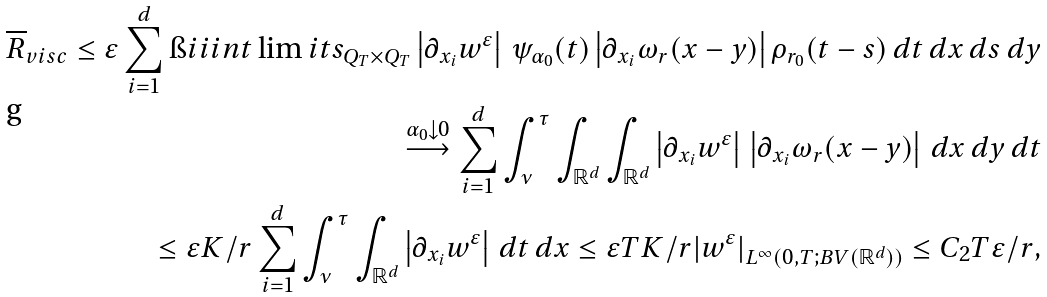<formula> <loc_0><loc_0><loc_500><loc_500>\overline { R } _ { v i s c } \leq \varepsilon \sum _ { i = 1 } ^ { d } \i i i i n t \lim i t s _ { Q _ { T } \times Q _ { T } } \left | \partial _ { x _ { i } } w ^ { \varepsilon } \right | \, \psi _ { \alpha _ { 0 } } ( t ) \left | \partial _ { x _ { i } } \omega _ { r } ( x - y ) \right | \rho _ { r _ { 0 } } ( t - s ) \, d t \, d x \, d s \, d y \\ \overset { \alpha _ { 0 } \downarrow 0 } { \longrightarrow } \sum _ { i = 1 } ^ { d } \int _ { \nu } ^ { \tau } \int _ { { \mathbb { R } } ^ { d } } \int _ { { \mathbb { R } } ^ { d } } \left | \partial _ { x _ { i } } w ^ { \varepsilon } \right | \, \left | \partial _ { x _ { i } } \omega _ { r } ( x - y ) \right | \, d x \, d y \, d t \\ \leq \varepsilon K / r \sum _ { i = 1 } ^ { d } \int _ { \nu } ^ { \tau } \int _ { { \mathbb { R } } ^ { d } } \left | \partial _ { x _ { i } } w ^ { \varepsilon } \right | \, d t \, d x \leq \varepsilon T K / r | w ^ { \varepsilon } | _ { L ^ { \infty } ( 0 , T ; B V ( { \mathbb { R } } ^ { d } ) ) } \leq C _ { 2 } T \varepsilon / r ,</formula> 